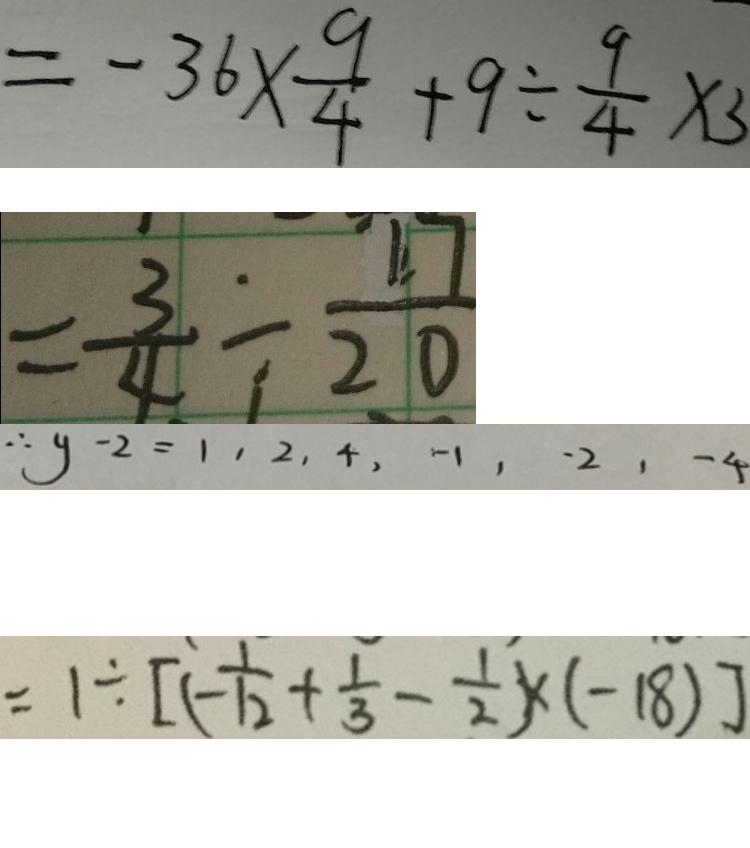<formula> <loc_0><loc_0><loc_500><loc_500>= - 3 6 \times \frac { 9 } { 4 } + 9 \div \frac { 9 } { 4 } \times 3 
 = \frac { 3 } { 4 } \div \frac { 1 7 } { 2 0 } 
 \therefore y - 2 = 1 , 2 , 4 , - 1 , - 2 , - 4 
 = 1 \div [ ( - \frac { 1 } { 1 2 } + \frac { 1 } { 3 } - \frac { 1 } { 2 } ) \times ( - 1 8 ) ]</formula> 